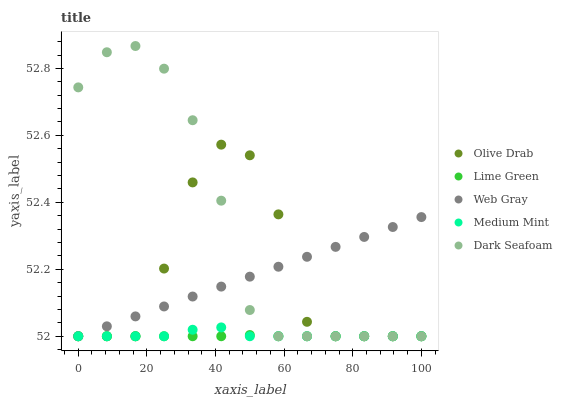Does Lime Green have the minimum area under the curve?
Answer yes or no. Yes. Does Dark Seafoam have the maximum area under the curve?
Answer yes or no. Yes. Does Web Gray have the minimum area under the curve?
Answer yes or no. No. Does Web Gray have the maximum area under the curve?
Answer yes or no. No. Is Web Gray the smoothest?
Answer yes or no. Yes. Is Olive Drab the roughest?
Answer yes or no. Yes. Is Dark Seafoam the smoothest?
Answer yes or no. No. Is Dark Seafoam the roughest?
Answer yes or no. No. Does Medium Mint have the lowest value?
Answer yes or no. Yes. Does Dark Seafoam have the highest value?
Answer yes or no. Yes. Does Web Gray have the highest value?
Answer yes or no. No. Does Dark Seafoam intersect Olive Drab?
Answer yes or no. Yes. Is Dark Seafoam less than Olive Drab?
Answer yes or no. No. Is Dark Seafoam greater than Olive Drab?
Answer yes or no. No. 